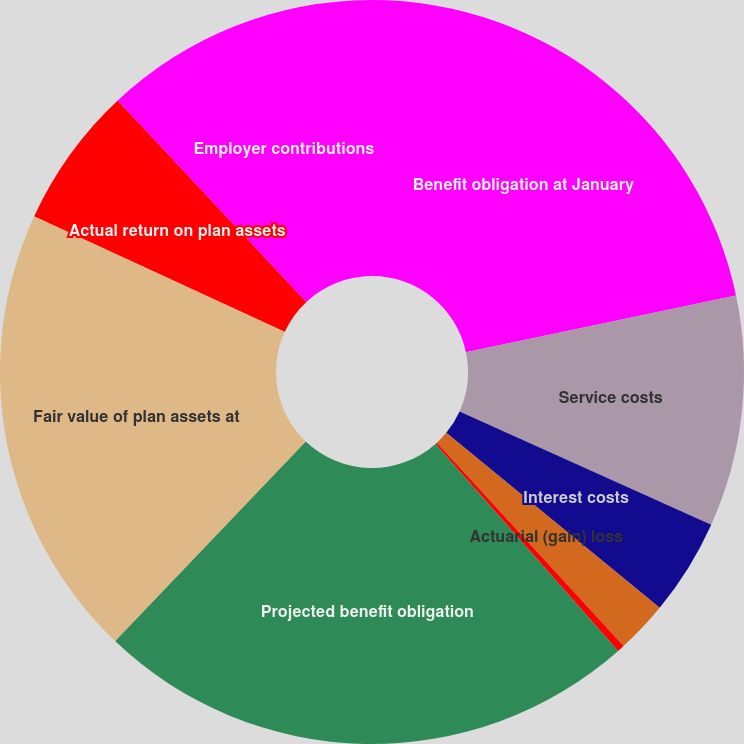Convert chart. <chart><loc_0><loc_0><loc_500><loc_500><pie_chart><fcel>Benefit obligation at January<fcel>Service costs<fcel>Interest costs<fcel>Actuarial (gain) loss<fcel>Benefit payments<fcel>Projected benefit obligation<fcel>Fair value of plan assets at<fcel>Actual return on plan assets<fcel>Employer contributions<nl><fcel>21.7%<fcel>10.03%<fcel>4.2%<fcel>2.25%<fcel>0.31%<fcel>23.64%<fcel>19.75%<fcel>6.14%<fcel>11.98%<nl></chart> 